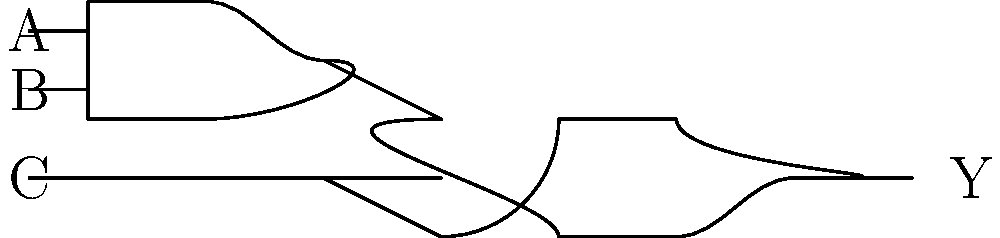As a tech-savvy individual familiar with digital systems, analyze the logic circuit diagram. What is the Boolean expression for the output Y in terms of inputs A, B, and C? Let's break this down step-by-step:

1. Identify the gates:
   - The first gate (top) is an AND gate
   - The second gate (bottom) is an OR gate

2. Analyze the connections:
   - Inputs A and B go into the AND gate
   - The output of the AND gate is one input to the OR gate
   - Input C is the other input to the OR gate
   - The output of the OR gate is Y

3. Express the output of the AND gate:
   - The AND gate output is $A \cdot B$

4. Express the final output Y:
   - Y is the OR of the AND gate output and C
   - In Boolean algebra, OR is represented by $+$
   - Therefore, $Y = (A \cdot B) + C$

5. This expression $(A \cdot B) + C$ is the simplest form for this circuit

The Boolean expression $Y = (A \cdot B) + C$ accurately represents the output of the given logic circuit.
Answer: $Y = (A \cdot B) + C$ 